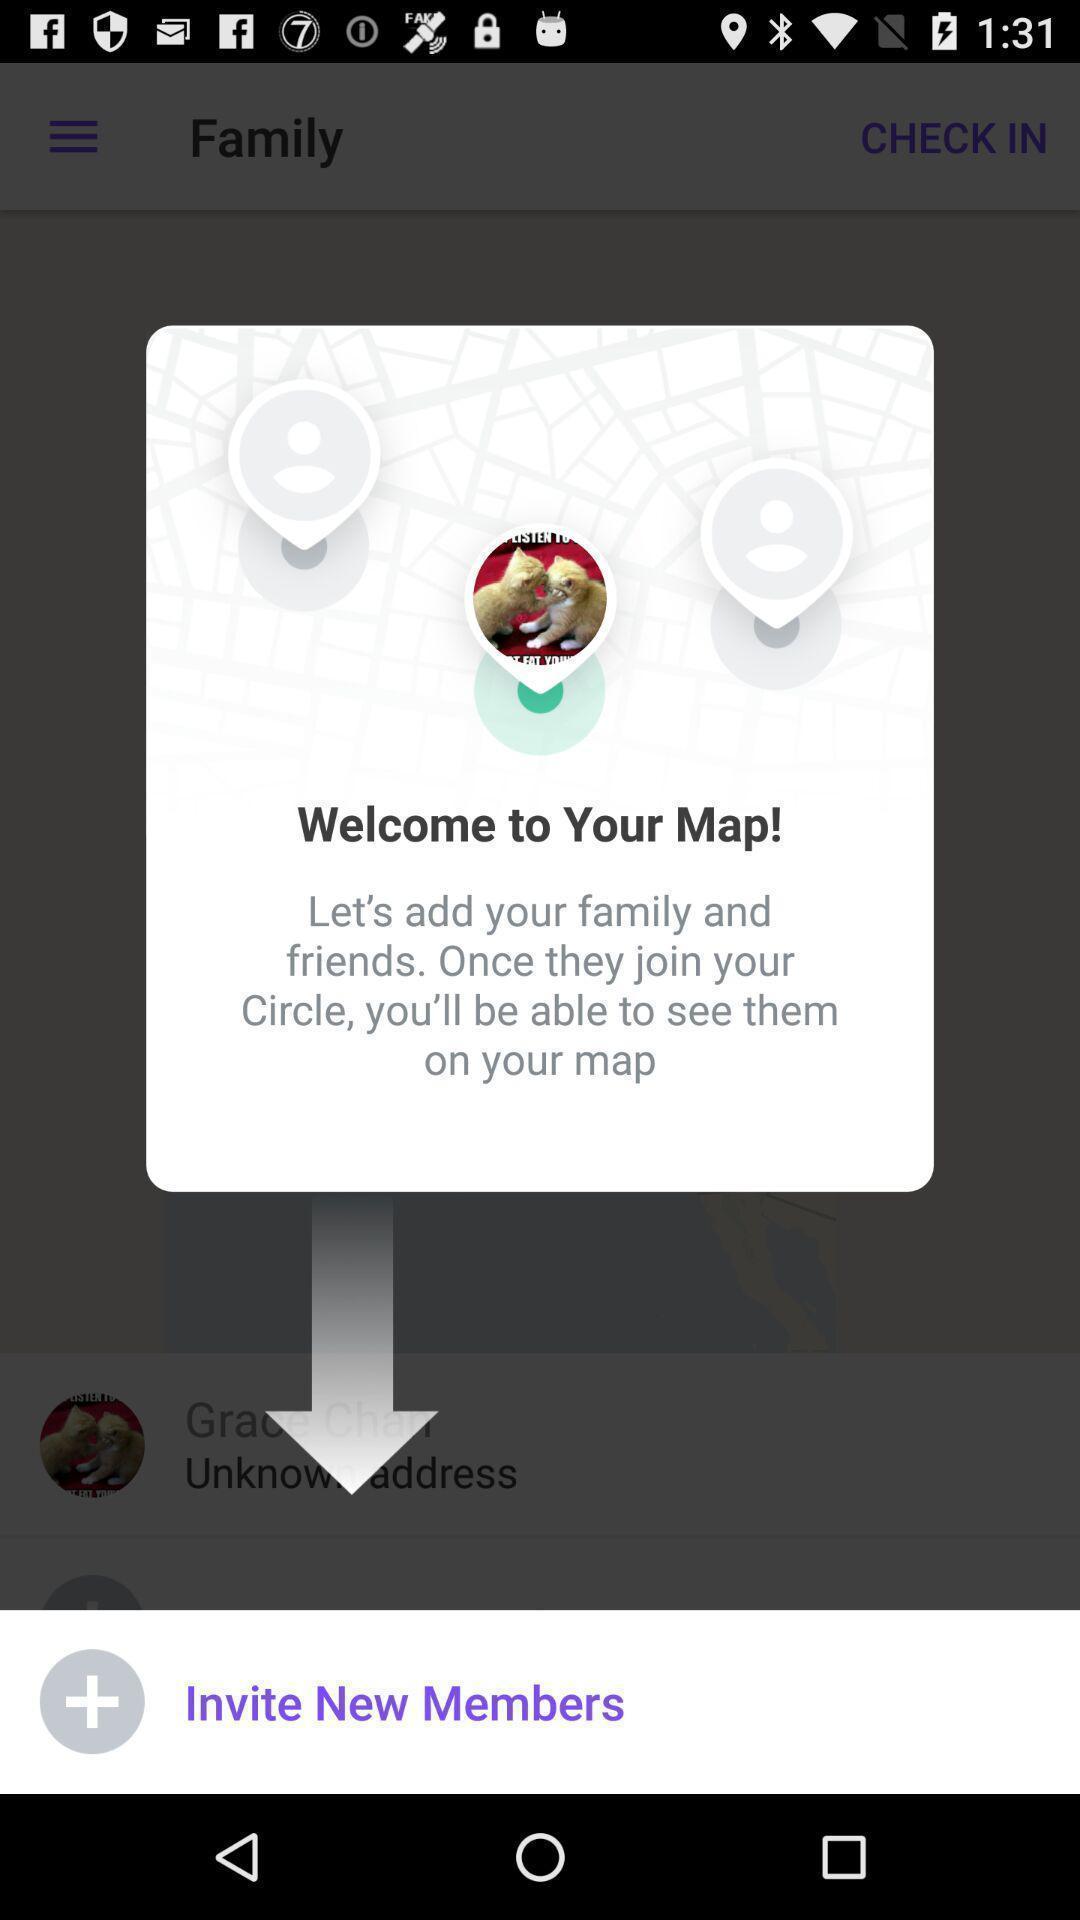What can you discern from this picture? Pop-up with info for a family locator app. 